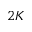Convert formula to latex. <formula><loc_0><loc_0><loc_500><loc_500>2 K</formula> 